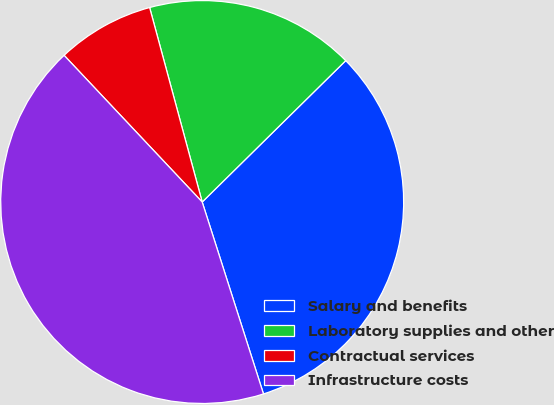Convert chart to OTSL. <chart><loc_0><loc_0><loc_500><loc_500><pie_chart><fcel>Salary and benefits<fcel>Laboratory supplies and other<fcel>Contractual services<fcel>Infrastructure costs<nl><fcel>32.46%<fcel>16.82%<fcel>7.82%<fcel>42.9%<nl></chart> 